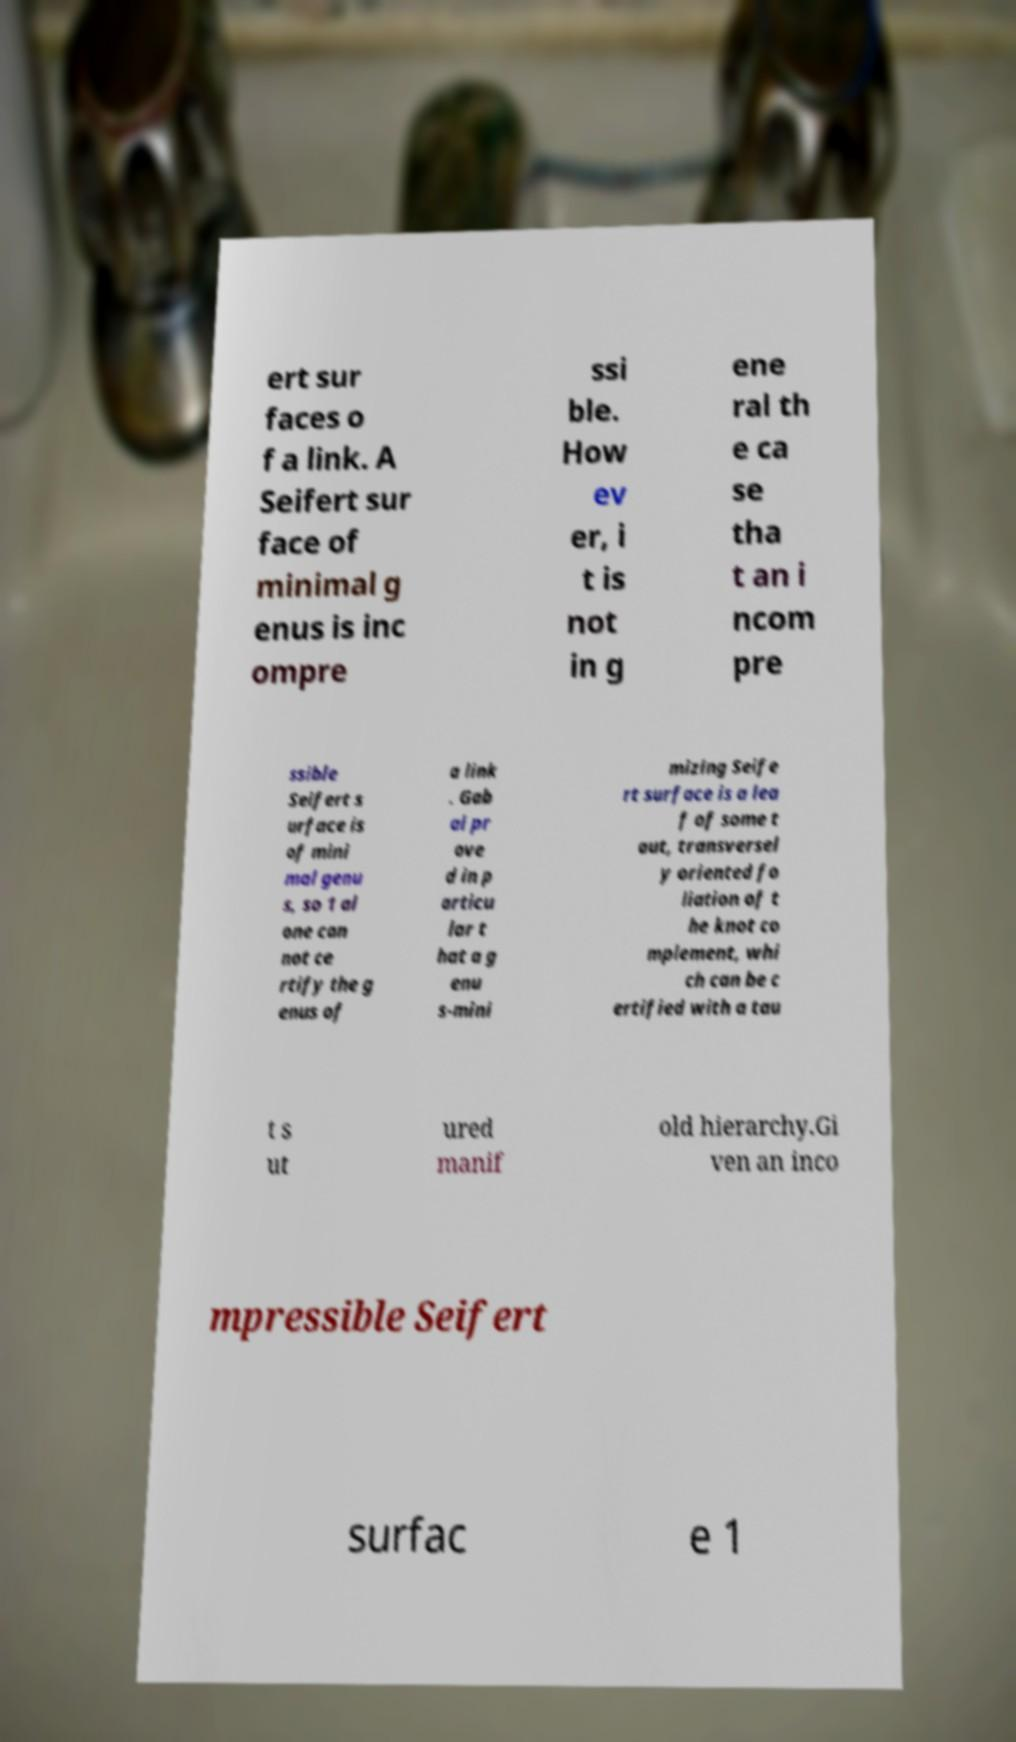Can you read and provide the text displayed in the image?This photo seems to have some interesting text. Can you extract and type it out for me? ert sur faces o f a link. A Seifert sur face of minimal g enus is inc ompre ssi ble. How ev er, i t is not in g ene ral th e ca se tha t an i ncom pre ssible Seifert s urface is of mini mal genu s, so 1 al one can not ce rtify the g enus of a link . Gab ai pr ove d in p articu lar t hat a g enu s-mini mizing Seife rt surface is a lea f of some t aut, transversel y oriented fo liation of t he knot co mplement, whi ch can be c ertified with a tau t s ut ured manif old hierarchy.Gi ven an inco mpressible Seifert surfac e 1 